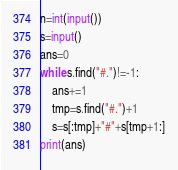<code> <loc_0><loc_0><loc_500><loc_500><_Python_>n=int(input())
s=input()
ans=0
while s.find("#.")!=-1:
    ans+=1
    tmp=s.find("#.")+1
    s=s[:tmp]+"#"+s[tmp+1:]
print(ans)</code> 